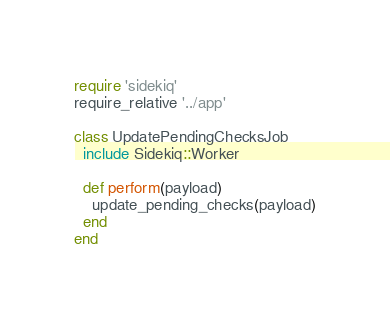<code> <loc_0><loc_0><loc_500><loc_500><_Ruby_>require 'sidekiq'
require_relative '../app'

class UpdatePendingChecksJob
  include Sidekiq::Worker

  def perform(payload)
    update_pending_checks(payload)
  end
end
</code> 